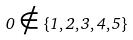<formula> <loc_0><loc_0><loc_500><loc_500>0 \notin \{ 1 , 2 , 3 , 4 , 5 \}</formula> 